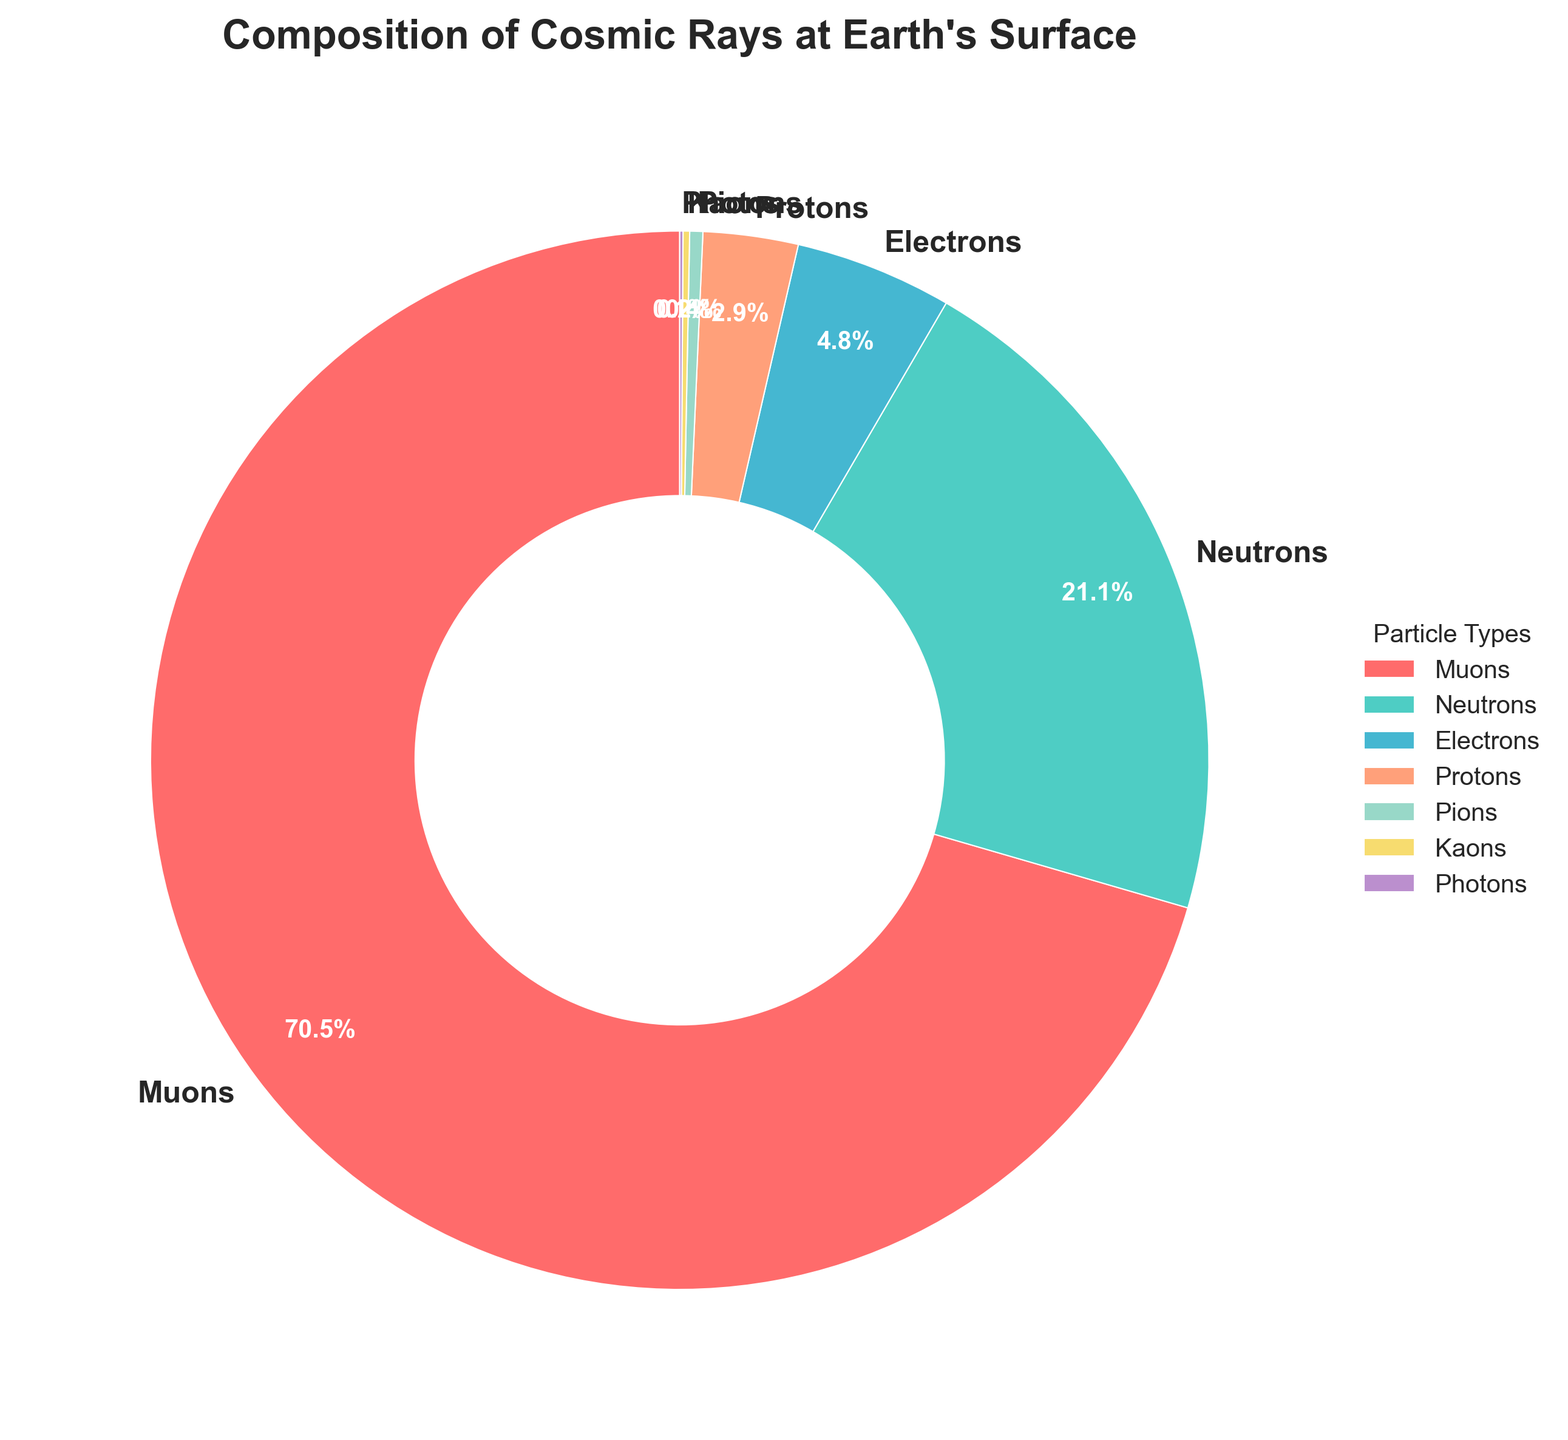What's the total percentage of Muons and Electrons combined? To find the total percentage of Muons and Electrons combined, sum the percentages of Muons and Electrons: 70.5% + 4.8% = 75.3%
Answer: 75.3% Which particle type has the second highest percentage? By visually inspecting the pie chart, it is evident that Neutrons have the second highest percentage after Muons, which is 21.1%
Answer: Neutrons How much greater is the percentage of Neutrons compared to Protons? Neutrons are 21.1%, and Protons are 2.9%. The difference is 21.1% - 2.9% = 18.2%
Answer: 18.2% What is the difference between the highest and lowest particle type percentages? The highest percentage is for Muons (70.5%) and the lowest is for Photons (0.1%). The difference is 70.5% - 0.1% = 70.4%
Answer: 70.4% What is the color associated with Pions in the chart? By inspecting the pie chart, we can see that Pions are represented by the green color slice
Answer: green Which particle types combined have less than 1% each? Summing up the percentages of Pions (0.4%), Kaons (0.2%), and Photons (0.1%) gives a total of 0.7%, which is less than 1%
Answer: Pions, Kaons, and Photons How much more is the percentage of Muons compared to the combined percentage of Photons and Kaons? Muons have 70.5%, while Photons and Kaons combined have 0.1% + 0.2% = 0.3%. The difference is 70.5% - 0.3% = 70.2%
Answer: 70.2% 